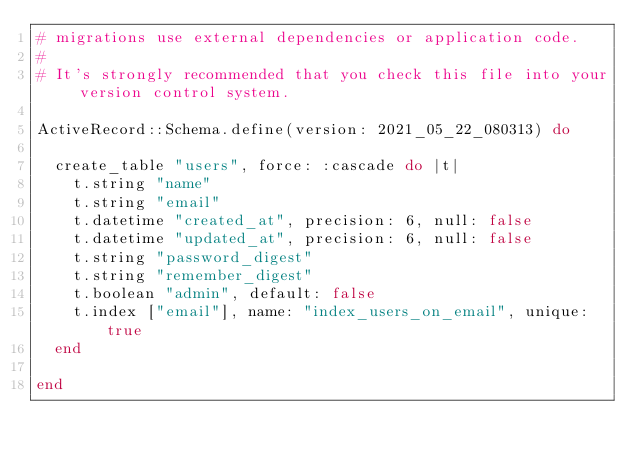Convert code to text. <code><loc_0><loc_0><loc_500><loc_500><_Ruby_># migrations use external dependencies or application code.
#
# It's strongly recommended that you check this file into your version control system.

ActiveRecord::Schema.define(version: 2021_05_22_080313) do

  create_table "users", force: :cascade do |t|
    t.string "name"
    t.string "email"
    t.datetime "created_at", precision: 6, null: false
    t.datetime "updated_at", precision: 6, null: false
    t.string "password_digest"
    t.string "remember_digest"
    t.boolean "admin", default: false
    t.index ["email"], name: "index_users_on_email", unique: true
  end

end
</code> 